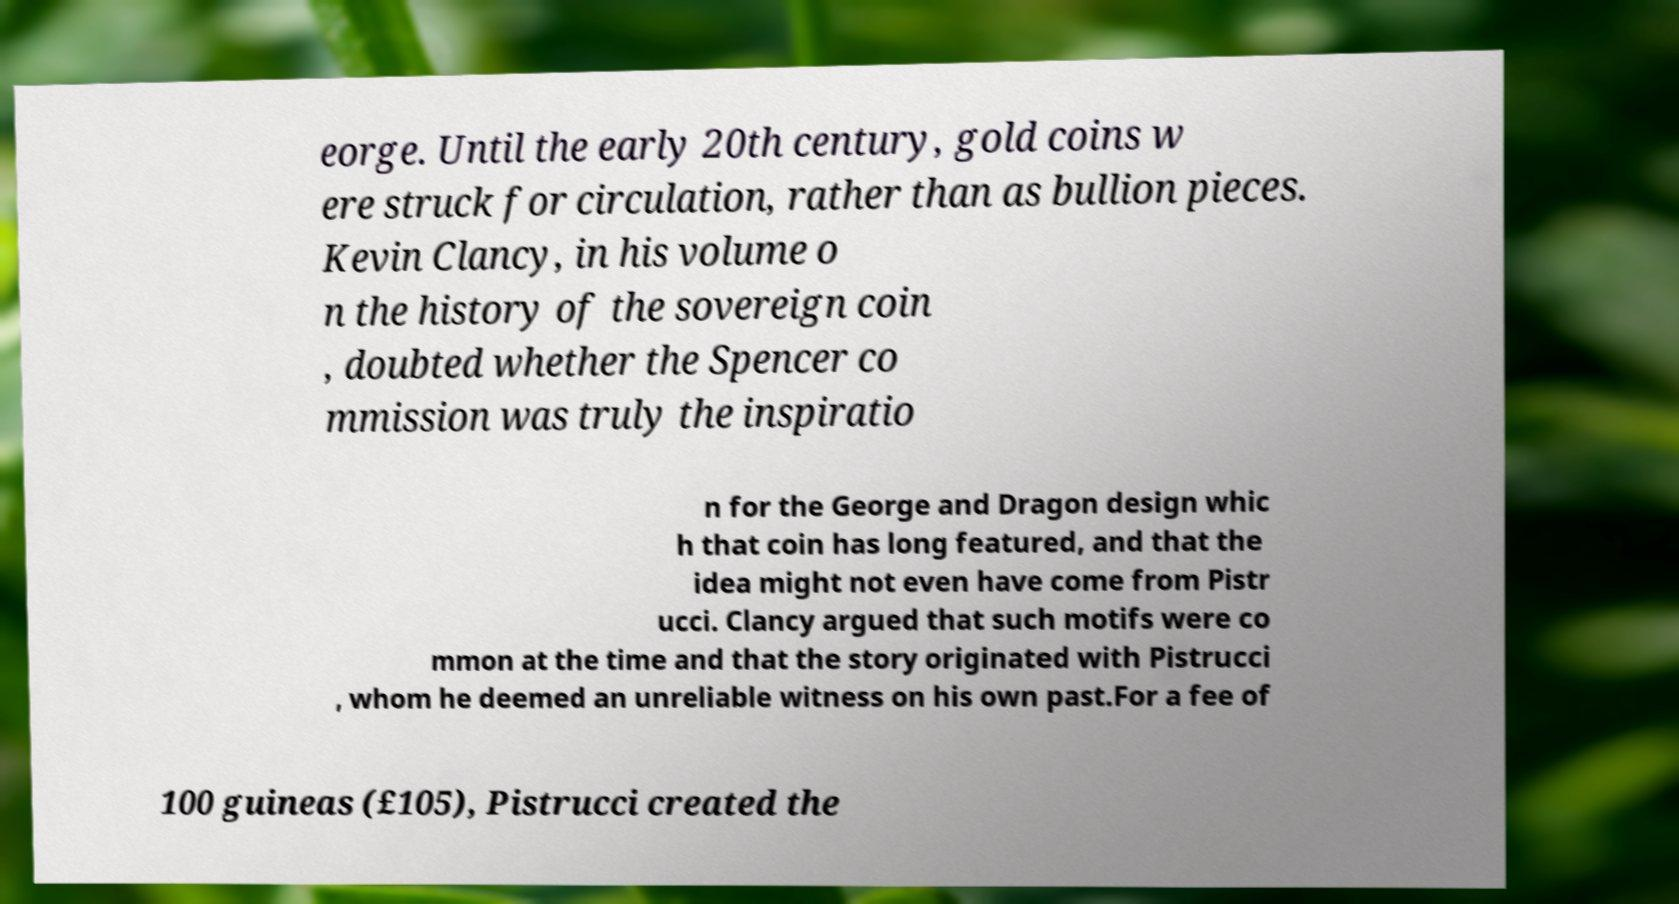Can you accurately transcribe the text from the provided image for me? eorge. Until the early 20th century, gold coins w ere struck for circulation, rather than as bullion pieces. Kevin Clancy, in his volume o n the history of the sovereign coin , doubted whether the Spencer co mmission was truly the inspiratio n for the George and Dragon design whic h that coin has long featured, and that the idea might not even have come from Pistr ucci. Clancy argued that such motifs were co mmon at the time and that the story originated with Pistrucci , whom he deemed an unreliable witness on his own past.For a fee of 100 guineas (£105), Pistrucci created the 